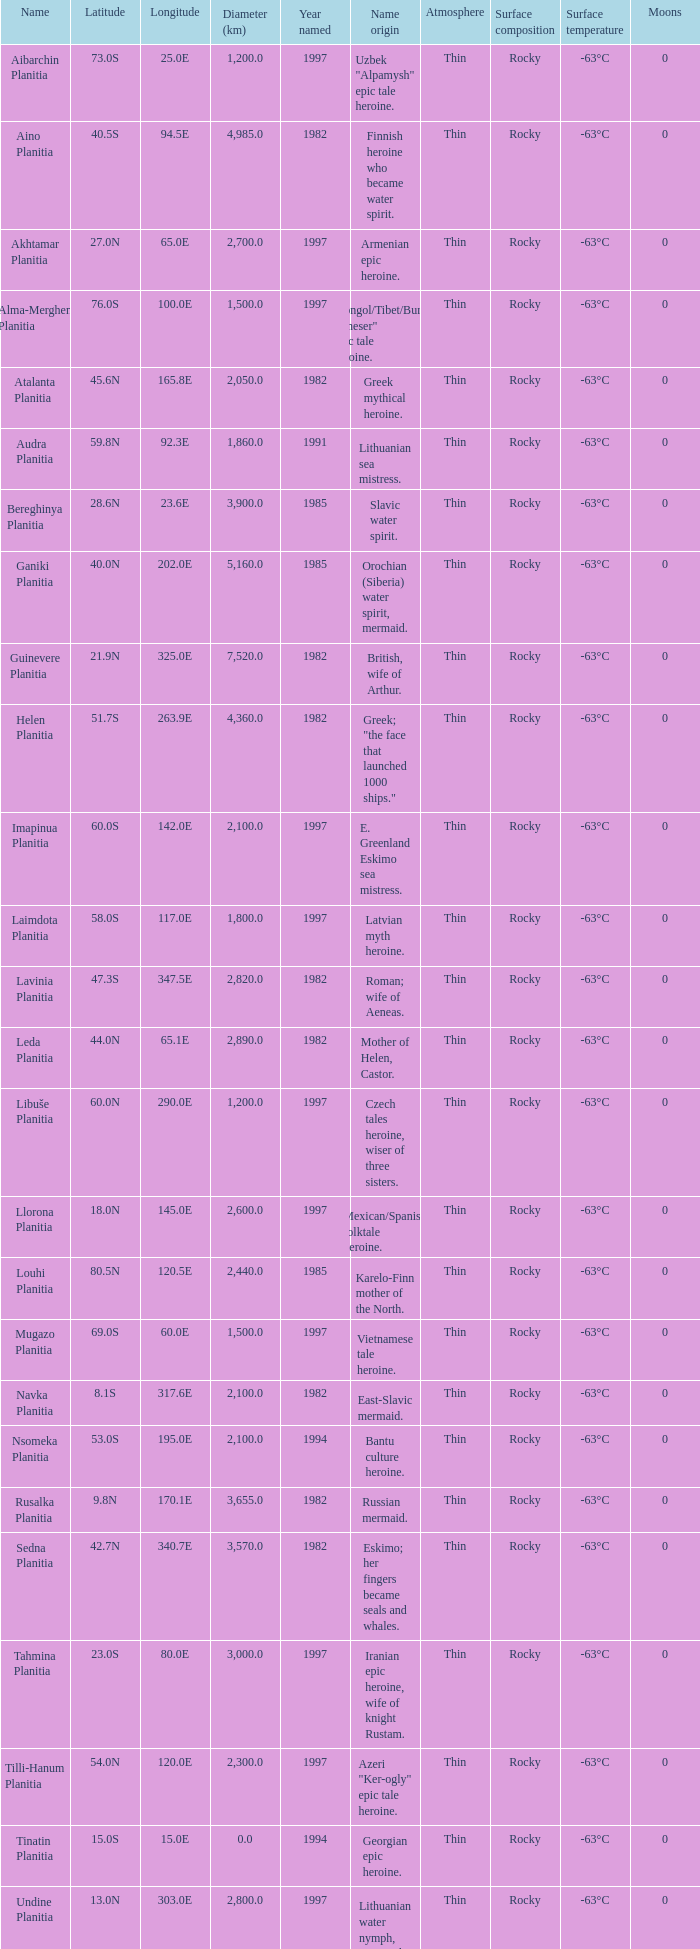What is the diameter (km) of feature of latitude 40.5s 4985.0. 